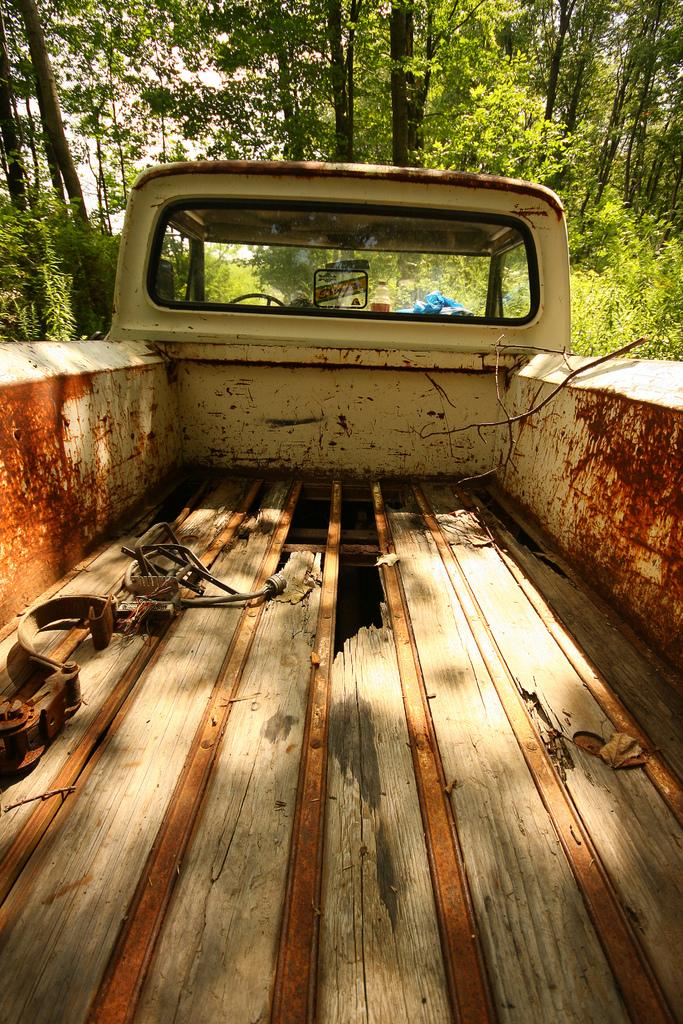What is the main subject of the image? The main subject of the image is a truck. Can you describe the color of the truck? The truck is in cream and red color. What can be seen on the side of the truck? There are many trees on the side of the truck. What is visible in the background of the image? The sky is white in the background of the image. What type of loss is being mourned at the cemetery in the image? There is no cemetery present in the image, so it is not possible to determine any loss being mourned. 